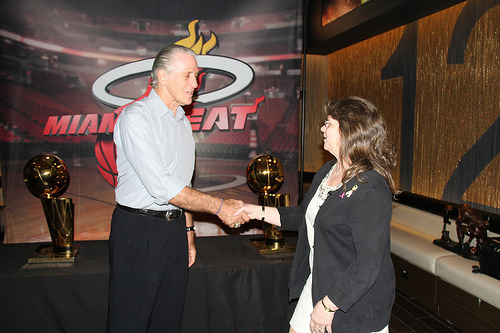<image>
Can you confirm if the award is on the woman? No. The award is not positioned on the woman. They may be near each other, but the award is not supported by or resting on top of the woman. Is the trophy on the woman? No. The trophy is not positioned on the woman. They may be near each other, but the trophy is not supported by or resting on top of the woman. 